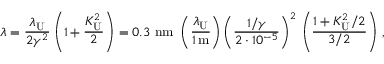<formula> <loc_0><loc_0><loc_500><loc_500>\lambda = \frac { \lambda _ { U } } { 2 \gamma ^ { 2 } } \left ( 1 + \frac { K _ { U } ^ { 2 } } { 2 } \right ) = 0 . 3 \ n m \ \left ( \frac { \lambda _ { U } } { 1 \, m } \right ) \left ( \frac { 1 / \gamma } { 2 \cdot 1 0 ^ { - 5 } } \right ) ^ { 2 } \, \left ( \frac { 1 + K _ { U } ^ { 2 } / 2 } { 3 / 2 } \right ) \, ,</formula> 